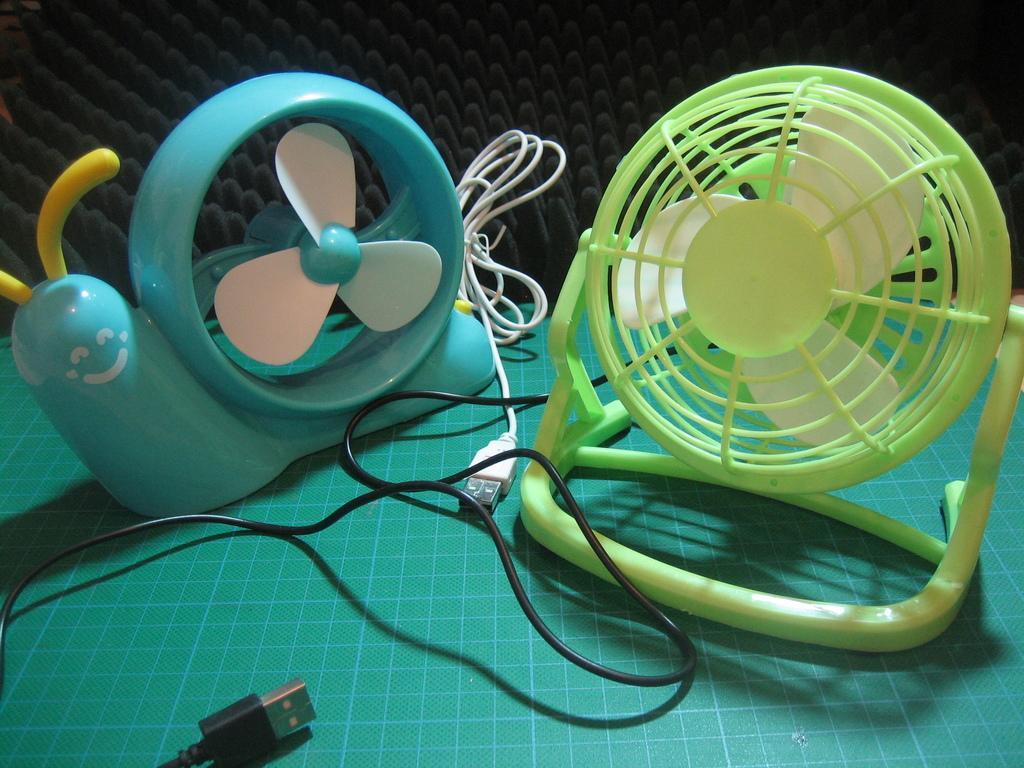In one or two sentences, can you explain what this image depicts? In this image we can see toy fans on the table with a cloth and there are wires and at the back we can see the black color object. 